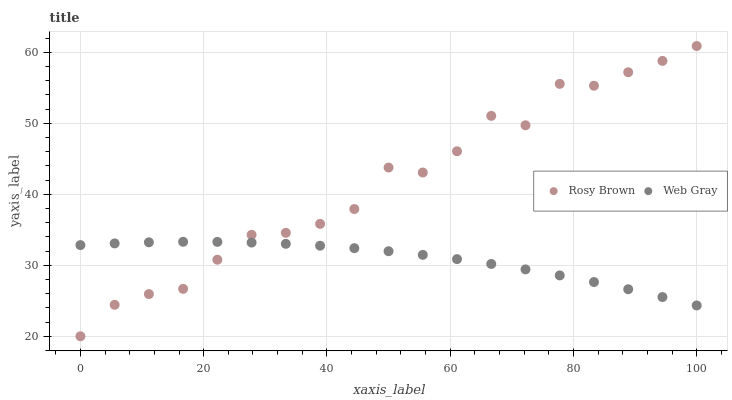Does Web Gray have the minimum area under the curve?
Answer yes or no. Yes. Does Rosy Brown have the maximum area under the curve?
Answer yes or no. Yes. Does Web Gray have the maximum area under the curve?
Answer yes or no. No. Is Web Gray the smoothest?
Answer yes or no. Yes. Is Rosy Brown the roughest?
Answer yes or no. Yes. Is Web Gray the roughest?
Answer yes or no. No. Does Rosy Brown have the lowest value?
Answer yes or no. Yes. Does Web Gray have the lowest value?
Answer yes or no. No. Does Rosy Brown have the highest value?
Answer yes or no. Yes. Does Web Gray have the highest value?
Answer yes or no. No. Does Rosy Brown intersect Web Gray?
Answer yes or no. Yes. Is Rosy Brown less than Web Gray?
Answer yes or no. No. Is Rosy Brown greater than Web Gray?
Answer yes or no. No. 